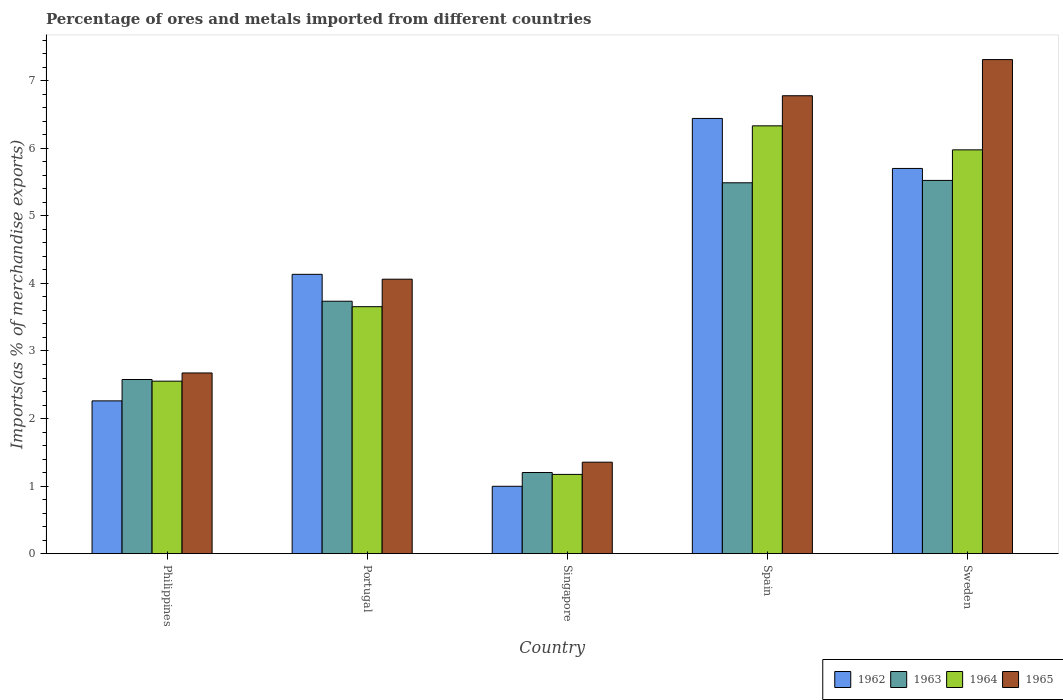How many different coloured bars are there?
Keep it short and to the point. 4. How many groups of bars are there?
Your answer should be very brief. 5. Are the number of bars on each tick of the X-axis equal?
Provide a succinct answer. Yes. What is the label of the 1st group of bars from the left?
Provide a succinct answer. Philippines. In how many cases, is the number of bars for a given country not equal to the number of legend labels?
Your answer should be compact. 0. What is the percentage of imports to different countries in 1964 in Singapore?
Give a very brief answer. 1.17. Across all countries, what is the maximum percentage of imports to different countries in 1965?
Keep it short and to the point. 7.31. Across all countries, what is the minimum percentage of imports to different countries in 1964?
Provide a succinct answer. 1.17. In which country was the percentage of imports to different countries in 1962 maximum?
Make the answer very short. Spain. In which country was the percentage of imports to different countries in 1963 minimum?
Your response must be concise. Singapore. What is the total percentage of imports to different countries in 1964 in the graph?
Offer a very short reply. 19.69. What is the difference between the percentage of imports to different countries in 1962 in Portugal and that in Sweden?
Provide a succinct answer. -1.57. What is the difference between the percentage of imports to different countries in 1962 in Singapore and the percentage of imports to different countries in 1965 in Portugal?
Ensure brevity in your answer.  -3.07. What is the average percentage of imports to different countries in 1963 per country?
Provide a succinct answer. 3.71. What is the difference between the percentage of imports to different countries of/in 1964 and percentage of imports to different countries of/in 1963 in Singapore?
Offer a very short reply. -0.03. In how many countries, is the percentage of imports to different countries in 1965 greater than 5 %?
Make the answer very short. 2. What is the ratio of the percentage of imports to different countries in 1965 in Philippines to that in Spain?
Give a very brief answer. 0.39. Is the percentage of imports to different countries in 1963 in Portugal less than that in Sweden?
Give a very brief answer. Yes. What is the difference between the highest and the second highest percentage of imports to different countries in 1962?
Give a very brief answer. -1.57. What is the difference between the highest and the lowest percentage of imports to different countries in 1962?
Give a very brief answer. 5.45. In how many countries, is the percentage of imports to different countries in 1965 greater than the average percentage of imports to different countries in 1965 taken over all countries?
Ensure brevity in your answer.  2. Is the sum of the percentage of imports to different countries in 1963 in Philippines and Sweden greater than the maximum percentage of imports to different countries in 1962 across all countries?
Provide a succinct answer. Yes. Is it the case that in every country, the sum of the percentage of imports to different countries in 1965 and percentage of imports to different countries in 1964 is greater than the sum of percentage of imports to different countries in 1962 and percentage of imports to different countries in 1963?
Give a very brief answer. No. What does the 3rd bar from the left in Singapore represents?
Ensure brevity in your answer.  1964. What does the 2nd bar from the right in Singapore represents?
Offer a very short reply. 1964. Is it the case that in every country, the sum of the percentage of imports to different countries in 1965 and percentage of imports to different countries in 1962 is greater than the percentage of imports to different countries in 1964?
Your response must be concise. Yes. How many bars are there?
Ensure brevity in your answer.  20. How many countries are there in the graph?
Keep it short and to the point. 5. What is the difference between two consecutive major ticks on the Y-axis?
Your answer should be very brief. 1. Are the values on the major ticks of Y-axis written in scientific E-notation?
Ensure brevity in your answer.  No. Does the graph contain grids?
Ensure brevity in your answer.  No. How many legend labels are there?
Make the answer very short. 4. How are the legend labels stacked?
Your response must be concise. Horizontal. What is the title of the graph?
Make the answer very short. Percentage of ores and metals imported from different countries. Does "1999" appear as one of the legend labels in the graph?
Ensure brevity in your answer.  No. What is the label or title of the Y-axis?
Ensure brevity in your answer.  Imports(as % of merchandise exports). What is the Imports(as % of merchandise exports) of 1962 in Philippines?
Give a very brief answer. 2.26. What is the Imports(as % of merchandise exports) of 1963 in Philippines?
Make the answer very short. 2.58. What is the Imports(as % of merchandise exports) in 1964 in Philippines?
Offer a terse response. 2.55. What is the Imports(as % of merchandise exports) of 1965 in Philippines?
Your response must be concise. 2.67. What is the Imports(as % of merchandise exports) of 1962 in Portugal?
Ensure brevity in your answer.  4.13. What is the Imports(as % of merchandise exports) of 1963 in Portugal?
Make the answer very short. 3.74. What is the Imports(as % of merchandise exports) in 1964 in Portugal?
Keep it short and to the point. 3.66. What is the Imports(as % of merchandise exports) of 1965 in Portugal?
Your answer should be very brief. 4.06. What is the Imports(as % of merchandise exports) of 1962 in Singapore?
Make the answer very short. 1. What is the Imports(as % of merchandise exports) of 1963 in Singapore?
Provide a short and direct response. 1.2. What is the Imports(as % of merchandise exports) of 1964 in Singapore?
Make the answer very short. 1.17. What is the Imports(as % of merchandise exports) in 1965 in Singapore?
Give a very brief answer. 1.35. What is the Imports(as % of merchandise exports) in 1962 in Spain?
Keep it short and to the point. 6.44. What is the Imports(as % of merchandise exports) of 1963 in Spain?
Your answer should be very brief. 5.49. What is the Imports(as % of merchandise exports) of 1964 in Spain?
Make the answer very short. 6.33. What is the Imports(as % of merchandise exports) of 1965 in Spain?
Offer a very short reply. 6.78. What is the Imports(as % of merchandise exports) of 1962 in Sweden?
Provide a short and direct response. 5.7. What is the Imports(as % of merchandise exports) in 1963 in Sweden?
Give a very brief answer. 5.52. What is the Imports(as % of merchandise exports) in 1964 in Sweden?
Offer a very short reply. 5.98. What is the Imports(as % of merchandise exports) of 1965 in Sweden?
Your answer should be compact. 7.31. Across all countries, what is the maximum Imports(as % of merchandise exports) of 1962?
Ensure brevity in your answer.  6.44. Across all countries, what is the maximum Imports(as % of merchandise exports) in 1963?
Keep it short and to the point. 5.52. Across all countries, what is the maximum Imports(as % of merchandise exports) in 1964?
Offer a very short reply. 6.33. Across all countries, what is the maximum Imports(as % of merchandise exports) in 1965?
Your answer should be very brief. 7.31. Across all countries, what is the minimum Imports(as % of merchandise exports) of 1962?
Offer a very short reply. 1. Across all countries, what is the minimum Imports(as % of merchandise exports) of 1963?
Make the answer very short. 1.2. Across all countries, what is the minimum Imports(as % of merchandise exports) in 1964?
Ensure brevity in your answer.  1.17. Across all countries, what is the minimum Imports(as % of merchandise exports) in 1965?
Ensure brevity in your answer.  1.35. What is the total Imports(as % of merchandise exports) of 1962 in the graph?
Your response must be concise. 19.54. What is the total Imports(as % of merchandise exports) of 1963 in the graph?
Your response must be concise. 18.53. What is the total Imports(as % of merchandise exports) of 1964 in the graph?
Give a very brief answer. 19.69. What is the total Imports(as % of merchandise exports) in 1965 in the graph?
Make the answer very short. 22.18. What is the difference between the Imports(as % of merchandise exports) in 1962 in Philippines and that in Portugal?
Your answer should be compact. -1.87. What is the difference between the Imports(as % of merchandise exports) in 1963 in Philippines and that in Portugal?
Give a very brief answer. -1.16. What is the difference between the Imports(as % of merchandise exports) of 1964 in Philippines and that in Portugal?
Make the answer very short. -1.1. What is the difference between the Imports(as % of merchandise exports) of 1965 in Philippines and that in Portugal?
Provide a short and direct response. -1.39. What is the difference between the Imports(as % of merchandise exports) in 1962 in Philippines and that in Singapore?
Your response must be concise. 1.26. What is the difference between the Imports(as % of merchandise exports) of 1963 in Philippines and that in Singapore?
Your answer should be compact. 1.38. What is the difference between the Imports(as % of merchandise exports) of 1964 in Philippines and that in Singapore?
Your response must be concise. 1.38. What is the difference between the Imports(as % of merchandise exports) of 1965 in Philippines and that in Singapore?
Provide a short and direct response. 1.32. What is the difference between the Imports(as % of merchandise exports) in 1962 in Philippines and that in Spain?
Provide a succinct answer. -4.18. What is the difference between the Imports(as % of merchandise exports) of 1963 in Philippines and that in Spain?
Keep it short and to the point. -2.91. What is the difference between the Imports(as % of merchandise exports) in 1964 in Philippines and that in Spain?
Provide a succinct answer. -3.78. What is the difference between the Imports(as % of merchandise exports) in 1965 in Philippines and that in Spain?
Offer a terse response. -4.1. What is the difference between the Imports(as % of merchandise exports) of 1962 in Philippines and that in Sweden?
Offer a very short reply. -3.44. What is the difference between the Imports(as % of merchandise exports) of 1963 in Philippines and that in Sweden?
Your answer should be very brief. -2.95. What is the difference between the Imports(as % of merchandise exports) of 1964 in Philippines and that in Sweden?
Give a very brief answer. -3.42. What is the difference between the Imports(as % of merchandise exports) of 1965 in Philippines and that in Sweden?
Keep it short and to the point. -4.64. What is the difference between the Imports(as % of merchandise exports) of 1962 in Portugal and that in Singapore?
Your answer should be compact. 3.14. What is the difference between the Imports(as % of merchandise exports) in 1963 in Portugal and that in Singapore?
Ensure brevity in your answer.  2.54. What is the difference between the Imports(as % of merchandise exports) in 1964 in Portugal and that in Singapore?
Keep it short and to the point. 2.48. What is the difference between the Imports(as % of merchandise exports) in 1965 in Portugal and that in Singapore?
Your answer should be very brief. 2.71. What is the difference between the Imports(as % of merchandise exports) of 1962 in Portugal and that in Spain?
Your response must be concise. -2.31. What is the difference between the Imports(as % of merchandise exports) of 1963 in Portugal and that in Spain?
Your response must be concise. -1.75. What is the difference between the Imports(as % of merchandise exports) of 1964 in Portugal and that in Spain?
Ensure brevity in your answer.  -2.68. What is the difference between the Imports(as % of merchandise exports) of 1965 in Portugal and that in Spain?
Ensure brevity in your answer.  -2.72. What is the difference between the Imports(as % of merchandise exports) in 1962 in Portugal and that in Sweden?
Your response must be concise. -1.57. What is the difference between the Imports(as % of merchandise exports) of 1963 in Portugal and that in Sweden?
Keep it short and to the point. -1.79. What is the difference between the Imports(as % of merchandise exports) of 1964 in Portugal and that in Sweden?
Your answer should be very brief. -2.32. What is the difference between the Imports(as % of merchandise exports) in 1965 in Portugal and that in Sweden?
Provide a succinct answer. -3.25. What is the difference between the Imports(as % of merchandise exports) in 1962 in Singapore and that in Spain?
Your answer should be very brief. -5.45. What is the difference between the Imports(as % of merchandise exports) in 1963 in Singapore and that in Spain?
Provide a succinct answer. -4.29. What is the difference between the Imports(as % of merchandise exports) of 1964 in Singapore and that in Spain?
Offer a very short reply. -5.16. What is the difference between the Imports(as % of merchandise exports) in 1965 in Singapore and that in Spain?
Offer a terse response. -5.42. What is the difference between the Imports(as % of merchandise exports) of 1962 in Singapore and that in Sweden?
Your answer should be very brief. -4.7. What is the difference between the Imports(as % of merchandise exports) in 1963 in Singapore and that in Sweden?
Your answer should be very brief. -4.32. What is the difference between the Imports(as % of merchandise exports) of 1964 in Singapore and that in Sweden?
Give a very brief answer. -4.8. What is the difference between the Imports(as % of merchandise exports) of 1965 in Singapore and that in Sweden?
Your answer should be compact. -5.96. What is the difference between the Imports(as % of merchandise exports) in 1962 in Spain and that in Sweden?
Give a very brief answer. 0.74. What is the difference between the Imports(as % of merchandise exports) of 1963 in Spain and that in Sweden?
Provide a short and direct response. -0.04. What is the difference between the Imports(as % of merchandise exports) in 1964 in Spain and that in Sweden?
Your answer should be very brief. 0.36. What is the difference between the Imports(as % of merchandise exports) of 1965 in Spain and that in Sweden?
Ensure brevity in your answer.  -0.54. What is the difference between the Imports(as % of merchandise exports) in 1962 in Philippines and the Imports(as % of merchandise exports) in 1963 in Portugal?
Provide a short and direct response. -1.47. What is the difference between the Imports(as % of merchandise exports) in 1962 in Philippines and the Imports(as % of merchandise exports) in 1964 in Portugal?
Keep it short and to the point. -1.39. What is the difference between the Imports(as % of merchandise exports) of 1962 in Philippines and the Imports(as % of merchandise exports) of 1965 in Portugal?
Give a very brief answer. -1.8. What is the difference between the Imports(as % of merchandise exports) in 1963 in Philippines and the Imports(as % of merchandise exports) in 1964 in Portugal?
Provide a succinct answer. -1.08. What is the difference between the Imports(as % of merchandise exports) of 1963 in Philippines and the Imports(as % of merchandise exports) of 1965 in Portugal?
Give a very brief answer. -1.48. What is the difference between the Imports(as % of merchandise exports) in 1964 in Philippines and the Imports(as % of merchandise exports) in 1965 in Portugal?
Offer a very short reply. -1.51. What is the difference between the Imports(as % of merchandise exports) in 1962 in Philippines and the Imports(as % of merchandise exports) in 1963 in Singapore?
Keep it short and to the point. 1.06. What is the difference between the Imports(as % of merchandise exports) of 1962 in Philippines and the Imports(as % of merchandise exports) of 1964 in Singapore?
Provide a short and direct response. 1.09. What is the difference between the Imports(as % of merchandise exports) in 1962 in Philippines and the Imports(as % of merchandise exports) in 1965 in Singapore?
Offer a very short reply. 0.91. What is the difference between the Imports(as % of merchandise exports) of 1963 in Philippines and the Imports(as % of merchandise exports) of 1964 in Singapore?
Make the answer very short. 1.4. What is the difference between the Imports(as % of merchandise exports) in 1963 in Philippines and the Imports(as % of merchandise exports) in 1965 in Singapore?
Ensure brevity in your answer.  1.22. What is the difference between the Imports(as % of merchandise exports) of 1964 in Philippines and the Imports(as % of merchandise exports) of 1965 in Singapore?
Your answer should be compact. 1.2. What is the difference between the Imports(as % of merchandise exports) in 1962 in Philippines and the Imports(as % of merchandise exports) in 1963 in Spain?
Provide a succinct answer. -3.23. What is the difference between the Imports(as % of merchandise exports) in 1962 in Philippines and the Imports(as % of merchandise exports) in 1964 in Spain?
Provide a succinct answer. -4.07. What is the difference between the Imports(as % of merchandise exports) of 1962 in Philippines and the Imports(as % of merchandise exports) of 1965 in Spain?
Offer a very short reply. -4.52. What is the difference between the Imports(as % of merchandise exports) in 1963 in Philippines and the Imports(as % of merchandise exports) in 1964 in Spain?
Make the answer very short. -3.75. What is the difference between the Imports(as % of merchandise exports) of 1963 in Philippines and the Imports(as % of merchandise exports) of 1965 in Spain?
Offer a terse response. -4.2. What is the difference between the Imports(as % of merchandise exports) in 1964 in Philippines and the Imports(as % of merchandise exports) in 1965 in Spain?
Provide a succinct answer. -4.22. What is the difference between the Imports(as % of merchandise exports) in 1962 in Philippines and the Imports(as % of merchandise exports) in 1963 in Sweden?
Give a very brief answer. -3.26. What is the difference between the Imports(as % of merchandise exports) in 1962 in Philippines and the Imports(as % of merchandise exports) in 1964 in Sweden?
Your response must be concise. -3.72. What is the difference between the Imports(as % of merchandise exports) in 1962 in Philippines and the Imports(as % of merchandise exports) in 1965 in Sweden?
Offer a terse response. -5.05. What is the difference between the Imports(as % of merchandise exports) of 1963 in Philippines and the Imports(as % of merchandise exports) of 1964 in Sweden?
Provide a succinct answer. -3.4. What is the difference between the Imports(as % of merchandise exports) in 1963 in Philippines and the Imports(as % of merchandise exports) in 1965 in Sweden?
Your answer should be compact. -4.74. What is the difference between the Imports(as % of merchandise exports) of 1964 in Philippines and the Imports(as % of merchandise exports) of 1965 in Sweden?
Ensure brevity in your answer.  -4.76. What is the difference between the Imports(as % of merchandise exports) in 1962 in Portugal and the Imports(as % of merchandise exports) in 1963 in Singapore?
Keep it short and to the point. 2.93. What is the difference between the Imports(as % of merchandise exports) in 1962 in Portugal and the Imports(as % of merchandise exports) in 1964 in Singapore?
Ensure brevity in your answer.  2.96. What is the difference between the Imports(as % of merchandise exports) in 1962 in Portugal and the Imports(as % of merchandise exports) in 1965 in Singapore?
Provide a succinct answer. 2.78. What is the difference between the Imports(as % of merchandise exports) of 1963 in Portugal and the Imports(as % of merchandise exports) of 1964 in Singapore?
Keep it short and to the point. 2.56. What is the difference between the Imports(as % of merchandise exports) of 1963 in Portugal and the Imports(as % of merchandise exports) of 1965 in Singapore?
Provide a short and direct response. 2.38. What is the difference between the Imports(as % of merchandise exports) in 1964 in Portugal and the Imports(as % of merchandise exports) in 1965 in Singapore?
Provide a short and direct response. 2.3. What is the difference between the Imports(as % of merchandise exports) in 1962 in Portugal and the Imports(as % of merchandise exports) in 1963 in Spain?
Give a very brief answer. -1.36. What is the difference between the Imports(as % of merchandise exports) in 1962 in Portugal and the Imports(as % of merchandise exports) in 1964 in Spain?
Offer a terse response. -2.2. What is the difference between the Imports(as % of merchandise exports) of 1962 in Portugal and the Imports(as % of merchandise exports) of 1965 in Spain?
Your response must be concise. -2.64. What is the difference between the Imports(as % of merchandise exports) of 1963 in Portugal and the Imports(as % of merchandise exports) of 1964 in Spain?
Provide a short and direct response. -2.6. What is the difference between the Imports(as % of merchandise exports) in 1963 in Portugal and the Imports(as % of merchandise exports) in 1965 in Spain?
Provide a succinct answer. -3.04. What is the difference between the Imports(as % of merchandise exports) in 1964 in Portugal and the Imports(as % of merchandise exports) in 1965 in Spain?
Offer a very short reply. -3.12. What is the difference between the Imports(as % of merchandise exports) of 1962 in Portugal and the Imports(as % of merchandise exports) of 1963 in Sweden?
Your answer should be very brief. -1.39. What is the difference between the Imports(as % of merchandise exports) in 1962 in Portugal and the Imports(as % of merchandise exports) in 1964 in Sweden?
Make the answer very short. -1.84. What is the difference between the Imports(as % of merchandise exports) of 1962 in Portugal and the Imports(as % of merchandise exports) of 1965 in Sweden?
Provide a short and direct response. -3.18. What is the difference between the Imports(as % of merchandise exports) in 1963 in Portugal and the Imports(as % of merchandise exports) in 1964 in Sweden?
Keep it short and to the point. -2.24. What is the difference between the Imports(as % of merchandise exports) of 1963 in Portugal and the Imports(as % of merchandise exports) of 1965 in Sweden?
Make the answer very short. -3.58. What is the difference between the Imports(as % of merchandise exports) of 1964 in Portugal and the Imports(as % of merchandise exports) of 1965 in Sweden?
Keep it short and to the point. -3.66. What is the difference between the Imports(as % of merchandise exports) in 1962 in Singapore and the Imports(as % of merchandise exports) in 1963 in Spain?
Provide a short and direct response. -4.49. What is the difference between the Imports(as % of merchandise exports) of 1962 in Singapore and the Imports(as % of merchandise exports) of 1964 in Spain?
Provide a succinct answer. -5.34. What is the difference between the Imports(as % of merchandise exports) in 1962 in Singapore and the Imports(as % of merchandise exports) in 1965 in Spain?
Make the answer very short. -5.78. What is the difference between the Imports(as % of merchandise exports) in 1963 in Singapore and the Imports(as % of merchandise exports) in 1964 in Spain?
Provide a short and direct response. -5.13. What is the difference between the Imports(as % of merchandise exports) of 1963 in Singapore and the Imports(as % of merchandise exports) of 1965 in Spain?
Your response must be concise. -5.58. What is the difference between the Imports(as % of merchandise exports) of 1964 in Singapore and the Imports(as % of merchandise exports) of 1965 in Spain?
Make the answer very short. -5.61. What is the difference between the Imports(as % of merchandise exports) of 1962 in Singapore and the Imports(as % of merchandise exports) of 1963 in Sweden?
Keep it short and to the point. -4.53. What is the difference between the Imports(as % of merchandise exports) in 1962 in Singapore and the Imports(as % of merchandise exports) in 1964 in Sweden?
Your answer should be compact. -4.98. What is the difference between the Imports(as % of merchandise exports) of 1962 in Singapore and the Imports(as % of merchandise exports) of 1965 in Sweden?
Offer a terse response. -6.32. What is the difference between the Imports(as % of merchandise exports) of 1963 in Singapore and the Imports(as % of merchandise exports) of 1964 in Sweden?
Give a very brief answer. -4.78. What is the difference between the Imports(as % of merchandise exports) in 1963 in Singapore and the Imports(as % of merchandise exports) in 1965 in Sweden?
Your answer should be compact. -6.11. What is the difference between the Imports(as % of merchandise exports) in 1964 in Singapore and the Imports(as % of merchandise exports) in 1965 in Sweden?
Keep it short and to the point. -6.14. What is the difference between the Imports(as % of merchandise exports) of 1962 in Spain and the Imports(as % of merchandise exports) of 1963 in Sweden?
Offer a very short reply. 0.92. What is the difference between the Imports(as % of merchandise exports) of 1962 in Spain and the Imports(as % of merchandise exports) of 1964 in Sweden?
Provide a short and direct response. 0.47. What is the difference between the Imports(as % of merchandise exports) of 1962 in Spain and the Imports(as % of merchandise exports) of 1965 in Sweden?
Provide a short and direct response. -0.87. What is the difference between the Imports(as % of merchandise exports) in 1963 in Spain and the Imports(as % of merchandise exports) in 1964 in Sweden?
Your response must be concise. -0.49. What is the difference between the Imports(as % of merchandise exports) in 1963 in Spain and the Imports(as % of merchandise exports) in 1965 in Sweden?
Offer a terse response. -1.82. What is the difference between the Imports(as % of merchandise exports) in 1964 in Spain and the Imports(as % of merchandise exports) in 1965 in Sweden?
Your answer should be compact. -0.98. What is the average Imports(as % of merchandise exports) of 1962 per country?
Provide a short and direct response. 3.91. What is the average Imports(as % of merchandise exports) in 1963 per country?
Keep it short and to the point. 3.71. What is the average Imports(as % of merchandise exports) in 1964 per country?
Make the answer very short. 3.94. What is the average Imports(as % of merchandise exports) of 1965 per country?
Your response must be concise. 4.44. What is the difference between the Imports(as % of merchandise exports) in 1962 and Imports(as % of merchandise exports) in 1963 in Philippines?
Give a very brief answer. -0.32. What is the difference between the Imports(as % of merchandise exports) of 1962 and Imports(as % of merchandise exports) of 1964 in Philippines?
Offer a terse response. -0.29. What is the difference between the Imports(as % of merchandise exports) in 1962 and Imports(as % of merchandise exports) in 1965 in Philippines?
Keep it short and to the point. -0.41. What is the difference between the Imports(as % of merchandise exports) of 1963 and Imports(as % of merchandise exports) of 1964 in Philippines?
Offer a terse response. 0.02. What is the difference between the Imports(as % of merchandise exports) of 1963 and Imports(as % of merchandise exports) of 1965 in Philippines?
Give a very brief answer. -0.1. What is the difference between the Imports(as % of merchandise exports) of 1964 and Imports(as % of merchandise exports) of 1965 in Philippines?
Your response must be concise. -0.12. What is the difference between the Imports(as % of merchandise exports) of 1962 and Imports(as % of merchandise exports) of 1963 in Portugal?
Provide a succinct answer. 0.4. What is the difference between the Imports(as % of merchandise exports) in 1962 and Imports(as % of merchandise exports) in 1964 in Portugal?
Your answer should be compact. 0.48. What is the difference between the Imports(as % of merchandise exports) of 1962 and Imports(as % of merchandise exports) of 1965 in Portugal?
Offer a terse response. 0.07. What is the difference between the Imports(as % of merchandise exports) in 1963 and Imports(as % of merchandise exports) in 1964 in Portugal?
Your answer should be very brief. 0.08. What is the difference between the Imports(as % of merchandise exports) in 1963 and Imports(as % of merchandise exports) in 1965 in Portugal?
Your answer should be very brief. -0.33. What is the difference between the Imports(as % of merchandise exports) in 1964 and Imports(as % of merchandise exports) in 1965 in Portugal?
Offer a very short reply. -0.41. What is the difference between the Imports(as % of merchandise exports) of 1962 and Imports(as % of merchandise exports) of 1963 in Singapore?
Offer a terse response. -0.2. What is the difference between the Imports(as % of merchandise exports) in 1962 and Imports(as % of merchandise exports) in 1964 in Singapore?
Keep it short and to the point. -0.18. What is the difference between the Imports(as % of merchandise exports) in 1962 and Imports(as % of merchandise exports) in 1965 in Singapore?
Offer a terse response. -0.36. What is the difference between the Imports(as % of merchandise exports) in 1963 and Imports(as % of merchandise exports) in 1964 in Singapore?
Ensure brevity in your answer.  0.03. What is the difference between the Imports(as % of merchandise exports) in 1963 and Imports(as % of merchandise exports) in 1965 in Singapore?
Your response must be concise. -0.15. What is the difference between the Imports(as % of merchandise exports) of 1964 and Imports(as % of merchandise exports) of 1965 in Singapore?
Your response must be concise. -0.18. What is the difference between the Imports(as % of merchandise exports) of 1962 and Imports(as % of merchandise exports) of 1964 in Spain?
Offer a very short reply. 0.11. What is the difference between the Imports(as % of merchandise exports) of 1962 and Imports(as % of merchandise exports) of 1965 in Spain?
Offer a terse response. -0.34. What is the difference between the Imports(as % of merchandise exports) of 1963 and Imports(as % of merchandise exports) of 1964 in Spain?
Your response must be concise. -0.84. What is the difference between the Imports(as % of merchandise exports) of 1963 and Imports(as % of merchandise exports) of 1965 in Spain?
Your answer should be compact. -1.29. What is the difference between the Imports(as % of merchandise exports) of 1964 and Imports(as % of merchandise exports) of 1965 in Spain?
Ensure brevity in your answer.  -0.45. What is the difference between the Imports(as % of merchandise exports) in 1962 and Imports(as % of merchandise exports) in 1963 in Sweden?
Your response must be concise. 0.18. What is the difference between the Imports(as % of merchandise exports) in 1962 and Imports(as % of merchandise exports) in 1964 in Sweden?
Make the answer very short. -0.28. What is the difference between the Imports(as % of merchandise exports) of 1962 and Imports(as % of merchandise exports) of 1965 in Sweden?
Provide a succinct answer. -1.61. What is the difference between the Imports(as % of merchandise exports) of 1963 and Imports(as % of merchandise exports) of 1964 in Sweden?
Provide a succinct answer. -0.45. What is the difference between the Imports(as % of merchandise exports) in 1963 and Imports(as % of merchandise exports) in 1965 in Sweden?
Your answer should be compact. -1.79. What is the difference between the Imports(as % of merchandise exports) in 1964 and Imports(as % of merchandise exports) in 1965 in Sweden?
Provide a succinct answer. -1.34. What is the ratio of the Imports(as % of merchandise exports) of 1962 in Philippines to that in Portugal?
Ensure brevity in your answer.  0.55. What is the ratio of the Imports(as % of merchandise exports) in 1963 in Philippines to that in Portugal?
Ensure brevity in your answer.  0.69. What is the ratio of the Imports(as % of merchandise exports) of 1964 in Philippines to that in Portugal?
Make the answer very short. 0.7. What is the ratio of the Imports(as % of merchandise exports) of 1965 in Philippines to that in Portugal?
Provide a succinct answer. 0.66. What is the ratio of the Imports(as % of merchandise exports) of 1962 in Philippines to that in Singapore?
Make the answer very short. 2.27. What is the ratio of the Imports(as % of merchandise exports) of 1963 in Philippines to that in Singapore?
Your answer should be compact. 2.15. What is the ratio of the Imports(as % of merchandise exports) of 1964 in Philippines to that in Singapore?
Give a very brief answer. 2.18. What is the ratio of the Imports(as % of merchandise exports) in 1965 in Philippines to that in Singapore?
Keep it short and to the point. 1.98. What is the ratio of the Imports(as % of merchandise exports) of 1962 in Philippines to that in Spain?
Ensure brevity in your answer.  0.35. What is the ratio of the Imports(as % of merchandise exports) of 1963 in Philippines to that in Spain?
Your answer should be very brief. 0.47. What is the ratio of the Imports(as % of merchandise exports) in 1964 in Philippines to that in Spain?
Your response must be concise. 0.4. What is the ratio of the Imports(as % of merchandise exports) in 1965 in Philippines to that in Spain?
Provide a succinct answer. 0.39. What is the ratio of the Imports(as % of merchandise exports) of 1962 in Philippines to that in Sweden?
Your answer should be very brief. 0.4. What is the ratio of the Imports(as % of merchandise exports) in 1963 in Philippines to that in Sweden?
Offer a very short reply. 0.47. What is the ratio of the Imports(as % of merchandise exports) of 1964 in Philippines to that in Sweden?
Make the answer very short. 0.43. What is the ratio of the Imports(as % of merchandise exports) in 1965 in Philippines to that in Sweden?
Offer a very short reply. 0.37. What is the ratio of the Imports(as % of merchandise exports) of 1962 in Portugal to that in Singapore?
Keep it short and to the point. 4.15. What is the ratio of the Imports(as % of merchandise exports) of 1963 in Portugal to that in Singapore?
Provide a succinct answer. 3.11. What is the ratio of the Imports(as % of merchandise exports) of 1964 in Portugal to that in Singapore?
Ensure brevity in your answer.  3.12. What is the ratio of the Imports(as % of merchandise exports) in 1965 in Portugal to that in Singapore?
Make the answer very short. 3. What is the ratio of the Imports(as % of merchandise exports) in 1962 in Portugal to that in Spain?
Provide a succinct answer. 0.64. What is the ratio of the Imports(as % of merchandise exports) of 1963 in Portugal to that in Spain?
Your answer should be very brief. 0.68. What is the ratio of the Imports(as % of merchandise exports) of 1964 in Portugal to that in Spain?
Give a very brief answer. 0.58. What is the ratio of the Imports(as % of merchandise exports) of 1965 in Portugal to that in Spain?
Offer a very short reply. 0.6. What is the ratio of the Imports(as % of merchandise exports) in 1962 in Portugal to that in Sweden?
Provide a short and direct response. 0.73. What is the ratio of the Imports(as % of merchandise exports) of 1963 in Portugal to that in Sweden?
Give a very brief answer. 0.68. What is the ratio of the Imports(as % of merchandise exports) in 1964 in Portugal to that in Sweden?
Keep it short and to the point. 0.61. What is the ratio of the Imports(as % of merchandise exports) of 1965 in Portugal to that in Sweden?
Offer a terse response. 0.56. What is the ratio of the Imports(as % of merchandise exports) in 1962 in Singapore to that in Spain?
Provide a short and direct response. 0.15. What is the ratio of the Imports(as % of merchandise exports) of 1963 in Singapore to that in Spain?
Keep it short and to the point. 0.22. What is the ratio of the Imports(as % of merchandise exports) in 1964 in Singapore to that in Spain?
Offer a terse response. 0.19. What is the ratio of the Imports(as % of merchandise exports) in 1965 in Singapore to that in Spain?
Provide a succinct answer. 0.2. What is the ratio of the Imports(as % of merchandise exports) of 1962 in Singapore to that in Sweden?
Ensure brevity in your answer.  0.17. What is the ratio of the Imports(as % of merchandise exports) of 1963 in Singapore to that in Sweden?
Provide a succinct answer. 0.22. What is the ratio of the Imports(as % of merchandise exports) in 1964 in Singapore to that in Sweden?
Your response must be concise. 0.2. What is the ratio of the Imports(as % of merchandise exports) in 1965 in Singapore to that in Sweden?
Your response must be concise. 0.19. What is the ratio of the Imports(as % of merchandise exports) of 1962 in Spain to that in Sweden?
Ensure brevity in your answer.  1.13. What is the ratio of the Imports(as % of merchandise exports) in 1963 in Spain to that in Sweden?
Give a very brief answer. 0.99. What is the ratio of the Imports(as % of merchandise exports) in 1964 in Spain to that in Sweden?
Ensure brevity in your answer.  1.06. What is the ratio of the Imports(as % of merchandise exports) of 1965 in Spain to that in Sweden?
Make the answer very short. 0.93. What is the difference between the highest and the second highest Imports(as % of merchandise exports) of 1962?
Your answer should be compact. 0.74. What is the difference between the highest and the second highest Imports(as % of merchandise exports) of 1963?
Offer a very short reply. 0.04. What is the difference between the highest and the second highest Imports(as % of merchandise exports) of 1964?
Ensure brevity in your answer.  0.36. What is the difference between the highest and the second highest Imports(as % of merchandise exports) in 1965?
Your answer should be very brief. 0.54. What is the difference between the highest and the lowest Imports(as % of merchandise exports) in 1962?
Keep it short and to the point. 5.45. What is the difference between the highest and the lowest Imports(as % of merchandise exports) in 1963?
Your response must be concise. 4.32. What is the difference between the highest and the lowest Imports(as % of merchandise exports) in 1964?
Offer a terse response. 5.16. What is the difference between the highest and the lowest Imports(as % of merchandise exports) of 1965?
Your response must be concise. 5.96. 